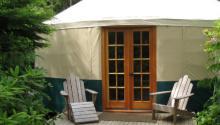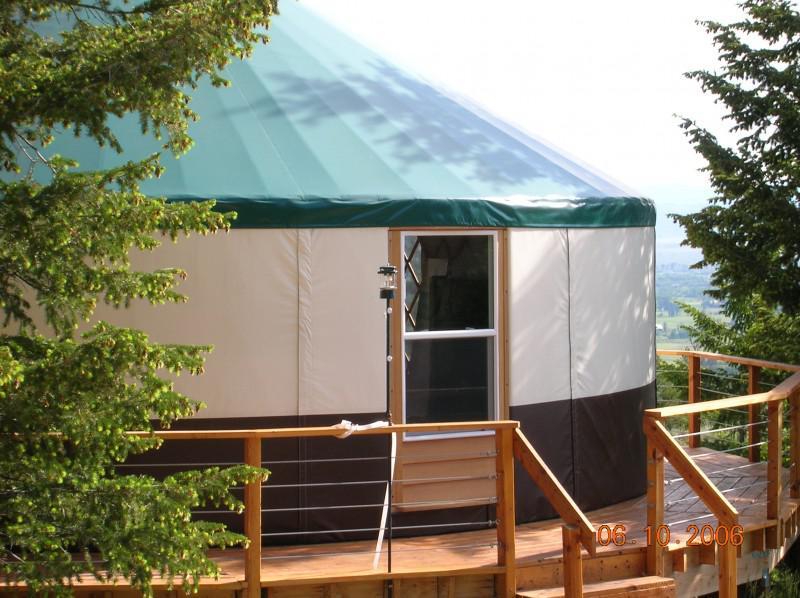The first image is the image on the left, the second image is the image on the right. Considering the images on both sides, is "There is a wooden rail around the hut in the image on the right." valid? Answer yes or no. Yes. The first image is the image on the left, the second image is the image on the right. For the images shown, is this caption "Left image shows a domed structure with darker top and bottom sections and a wooden railed walkway curving around it." true? Answer yes or no. No. 